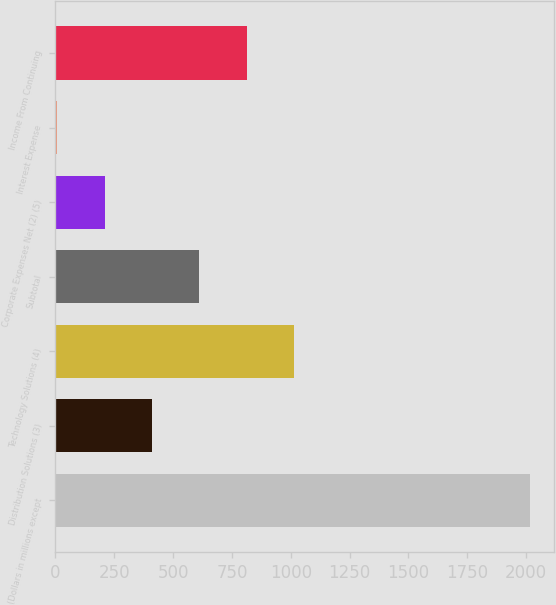<chart> <loc_0><loc_0><loc_500><loc_500><bar_chart><fcel>(Dollars in millions except<fcel>Distribution Solutions (3)<fcel>Technology Solutions (4)<fcel>Subtotal<fcel>Corporate Expenses Net (2) (5)<fcel>Interest Expense<fcel>Income From Continuing<nl><fcel>2018<fcel>410<fcel>1013<fcel>611<fcel>209<fcel>8<fcel>812<nl></chart> 